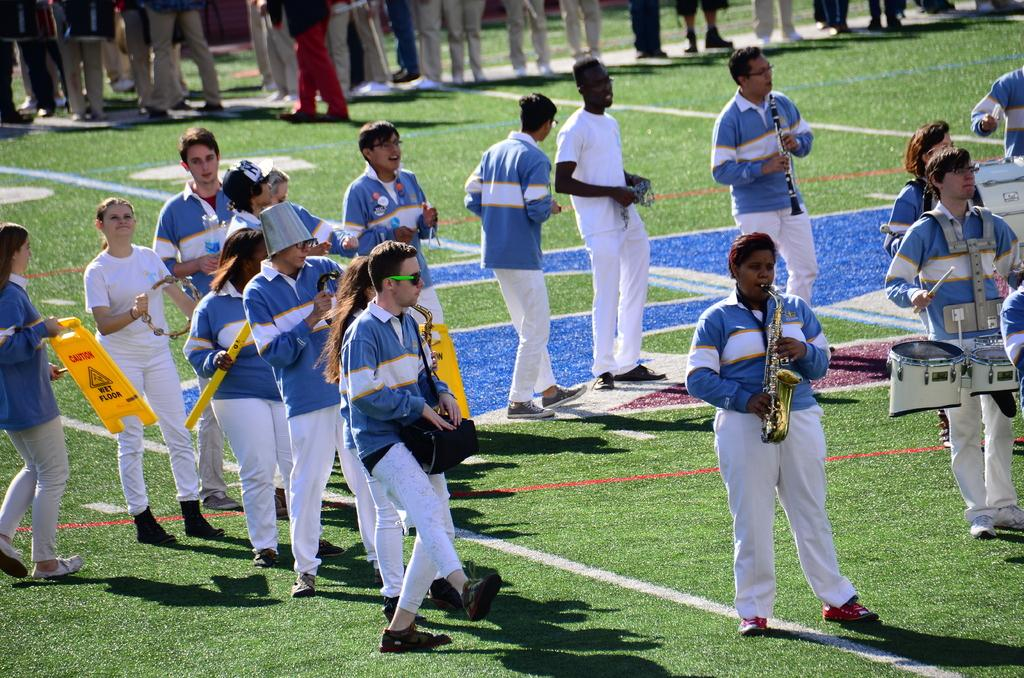What are the people in the image doing? The people in the image are playing musical instruments and dancing on the grassland. What are the people wearing? The people are wearing blue shirts. Are there any other people visible in the image? Yes, there are people standing in the background of the image. What type of prison can be seen in the image? There is no prison present in the image. How many toes can be seen on the people in the image? The image does not show the people's toes, so it cannot be determined from the image. 